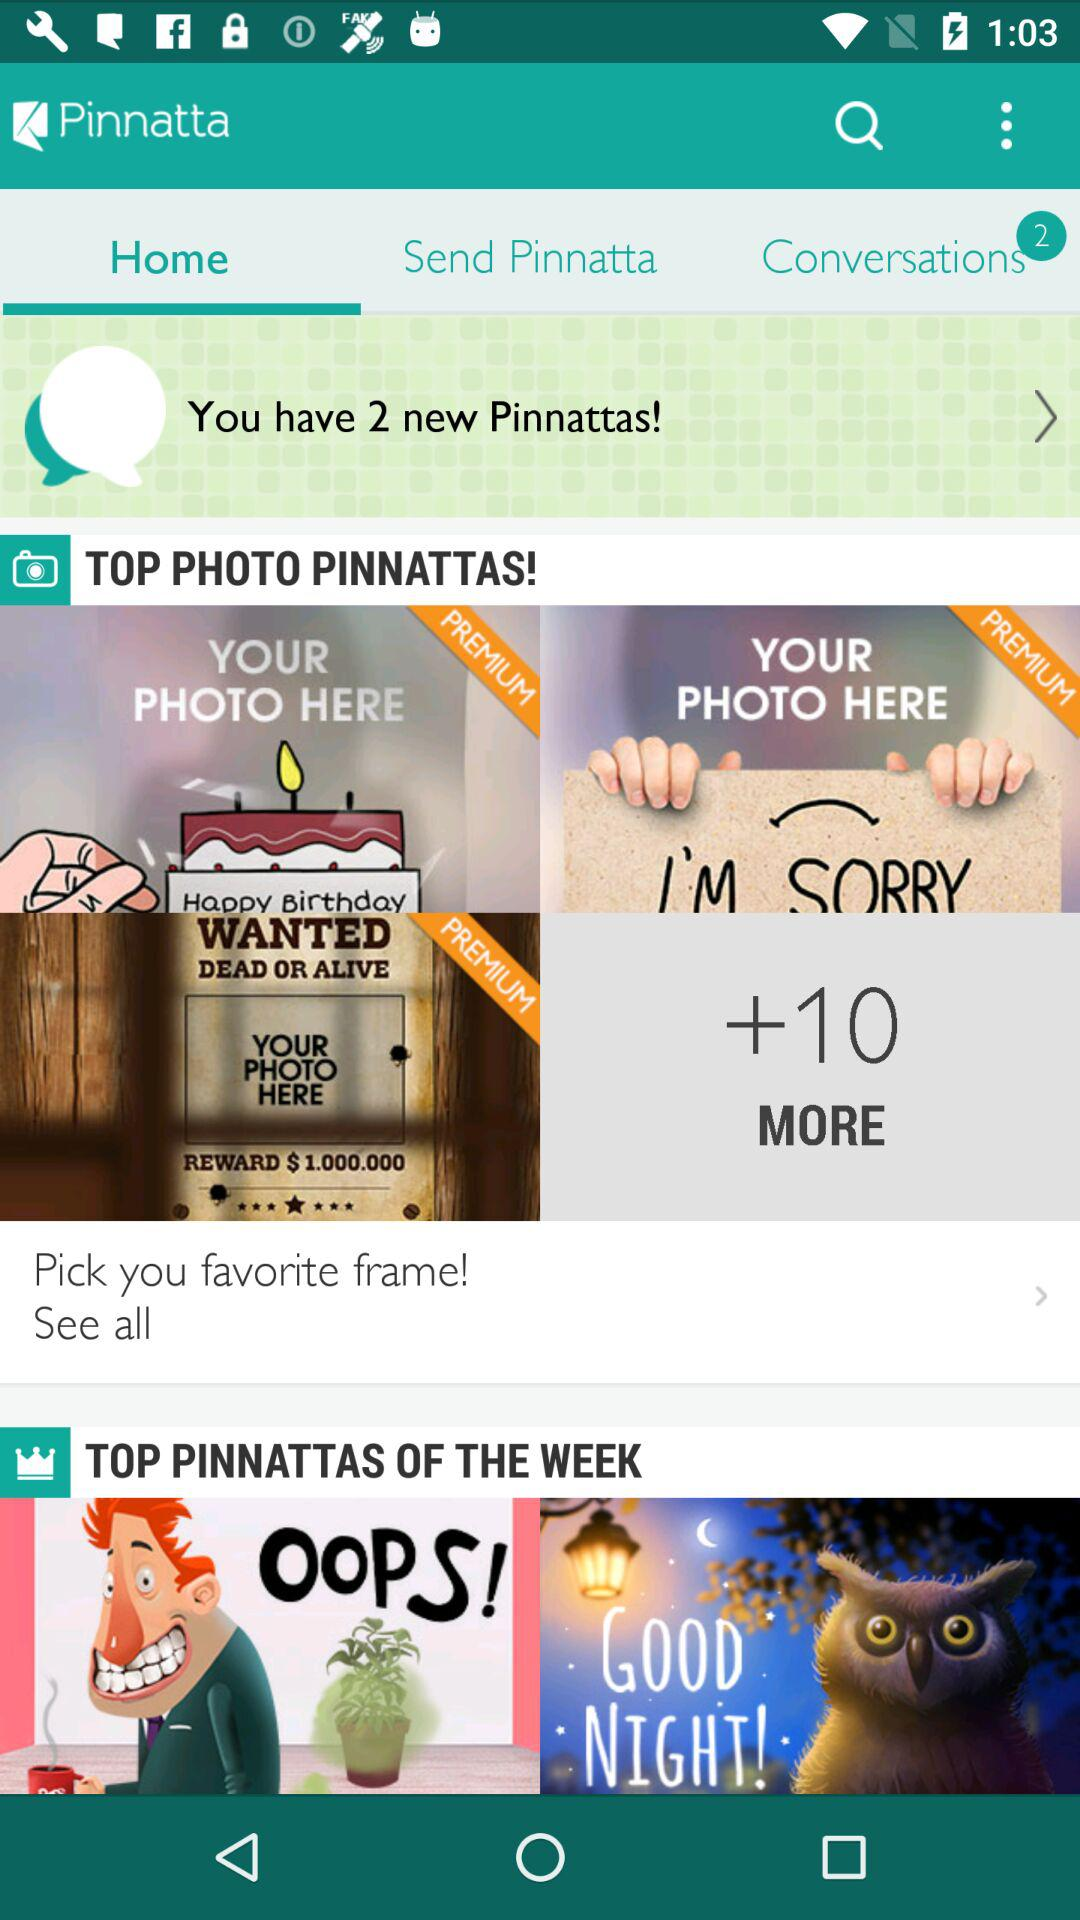How many notifications are there for the "Conversations"? There are 2 notifications for the "Conversations". 